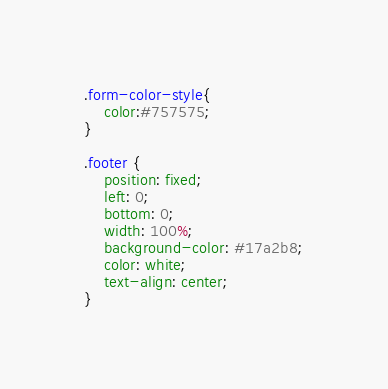<code> <loc_0><loc_0><loc_500><loc_500><_CSS_>.form-color-style{
    color:#757575;
}

.footer {
    position: fixed;
    left: 0;
    bottom: 0;
    width: 100%;
    background-color: #17a2b8;
    color: white;
    text-align: center;
}
</code> 